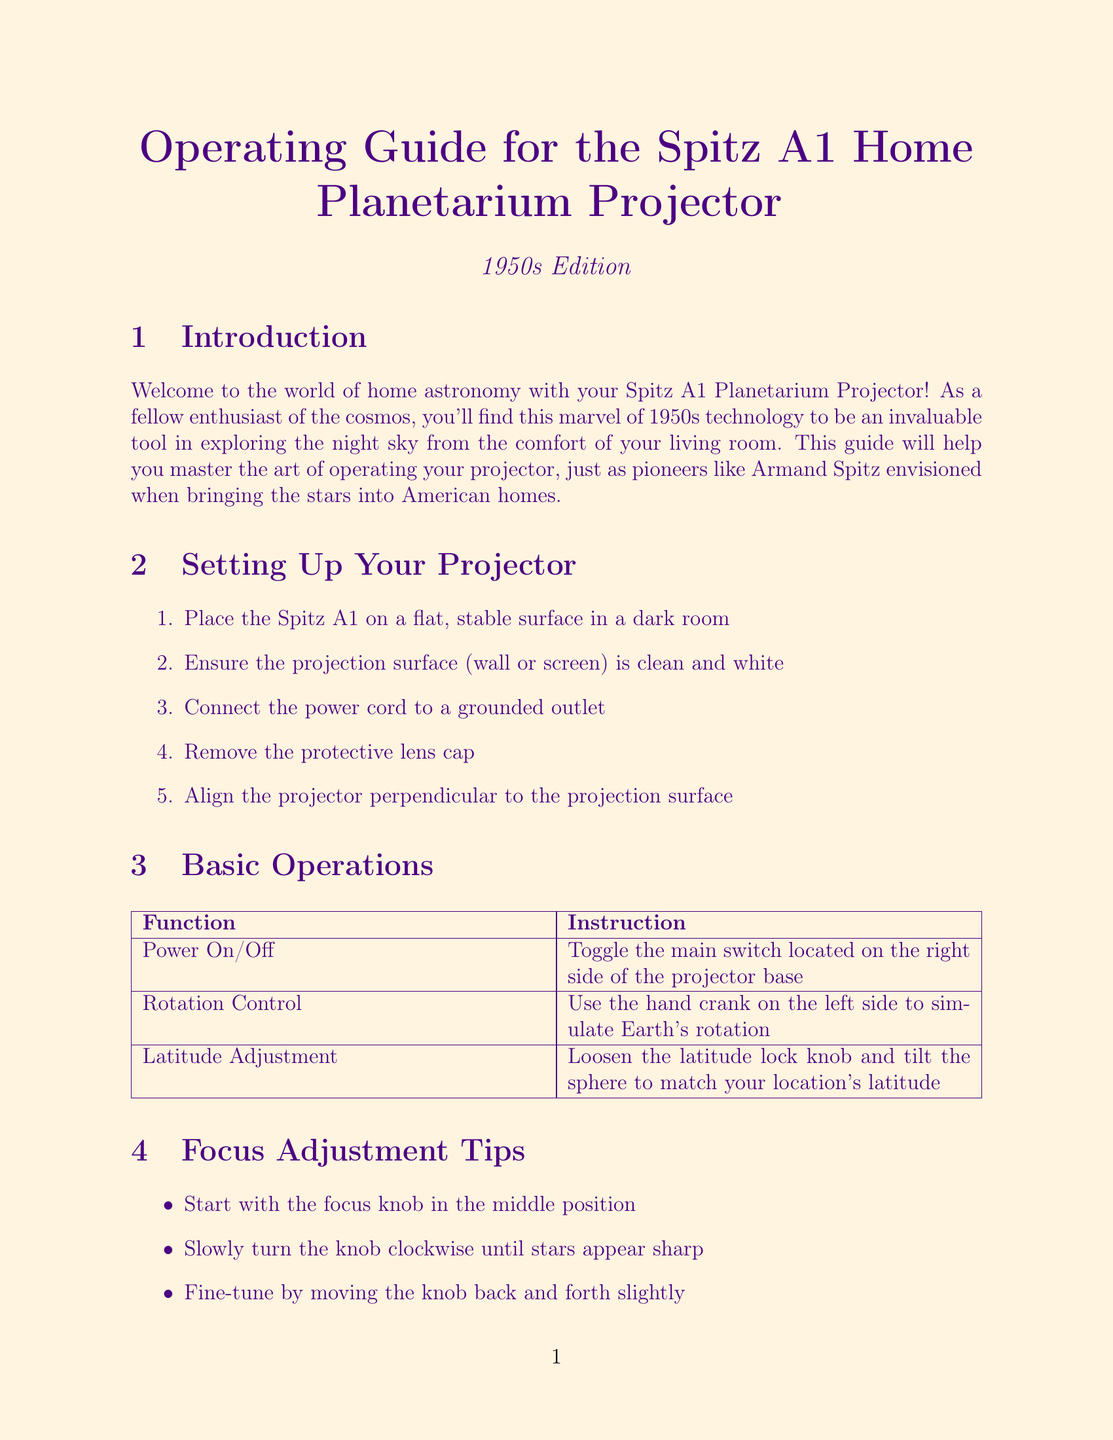What is the title of the manual? The title of the manual is stated on the cover page of the document.
Answer: Operating Guide for the Spitz A1 Home Planetarium Projector (1950s Edition) How many steps are in the "Setting Up Your Projector" section? The number of steps listed in that section can be counted directly from the content.
Answer: 5 What is the first tip for focus adjustment? This information directly lists the tips for focus adjustment found in the document.
Answer: Start with the focus knob in the middle position What problem is associated with a dim projection? This problem can be found under the troubleshooting section identifying a specific issue.
Answer: Dim projection Which notable feature is found in the Northern Hemisphere Winter Sky chart? This information is included in the appendix list of notable features in each seasonal chart.
Answer: Orion What is the required maintenance task for the rotation mechanism? This relates to the maintenance section, which prescribes actions to keep the projector functioning well.
Answer: Lubricate the rotation mechanism annually with provided oil What shade is used for the document background? This detail relates to visual elements within the document that enhances readability.
Answer: starlight How do you adjust the latitude on the projector? This question addresses the operation of the projector found in the basic operations section.
Answer: Loosen the latitude lock knob and tilt the sphere to match your location's latitude 